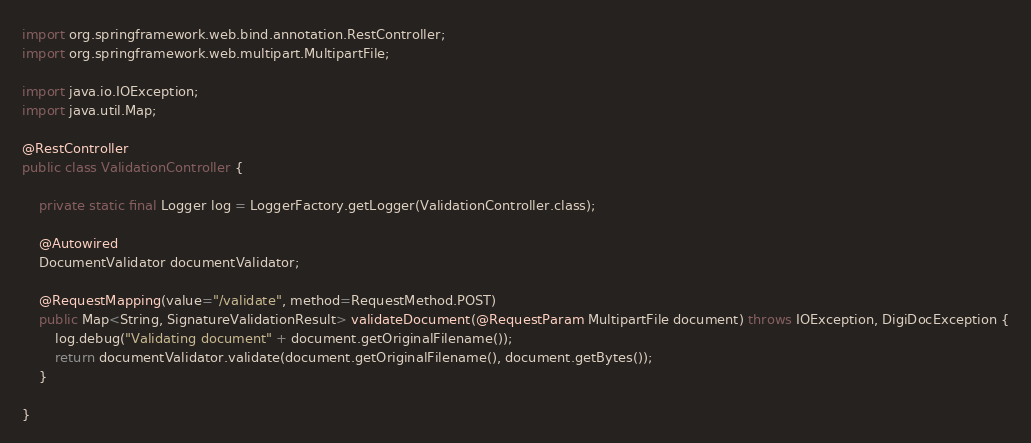Convert code to text. <code><loc_0><loc_0><loc_500><loc_500><_Java_>import org.springframework.web.bind.annotation.RestController;
import org.springframework.web.multipart.MultipartFile;

import java.io.IOException;
import java.util.Map;

@RestController
public class ValidationController {

    private static final Logger log = LoggerFactory.getLogger(ValidationController.class);

    @Autowired
    DocumentValidator documentValidator;

    @RequestMapping(value="/validate", method=RequestMethod.POST)
    public Map<String, SignatureValidationResult> validateDocument(@RequestParam MultipartFile document) throws IOException, DigiDocException {
        log.debug("Validating document" + document.getOriginalFilename());
        return documentValidator.validate(document.getOriginalFilename(), document.getBytes());
    }

} 
</code> 